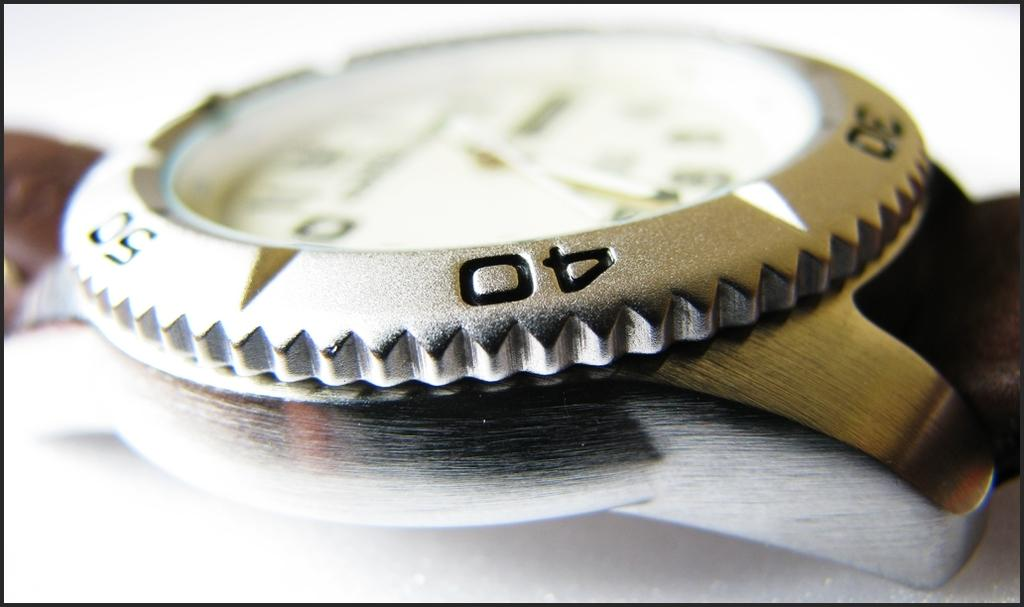<image>
Share a concise interpretation of the image provided. The number on the watch in the center is 40 